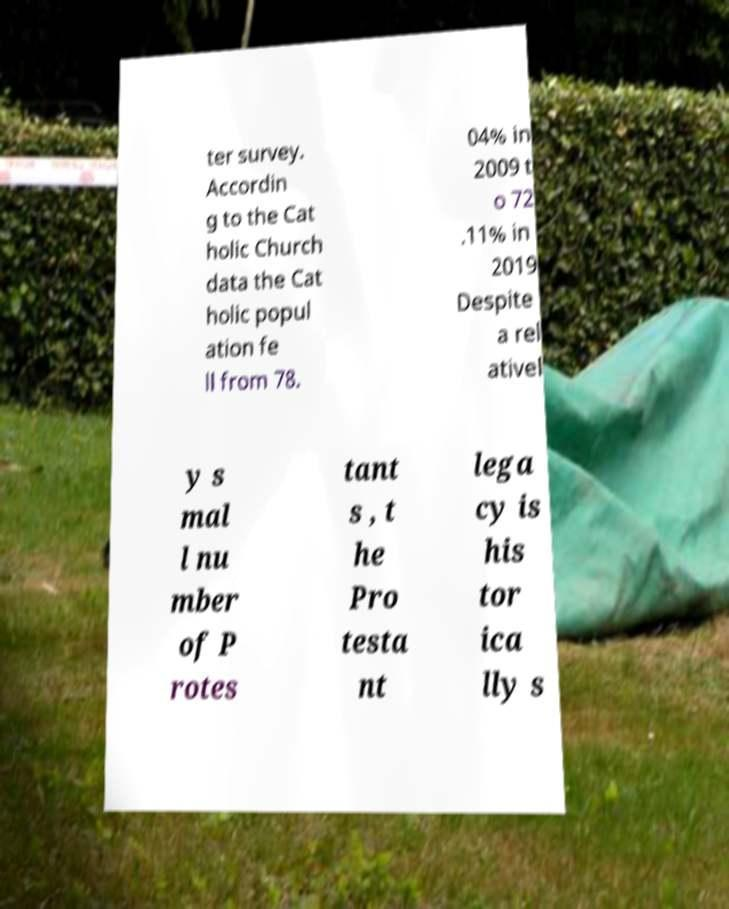I need the written content from this picture converted into text. Can you do that? ter survey. Accordin g to the Cat holic Church data the Cat holic popul ation fe ll from 78. 04% in 2009 t o 72 .11% in 2019 Despite a rel ativel y s mal l nu mber of P rotes tant s , t he Pro testa nt lega cy is his tor ica lly s 